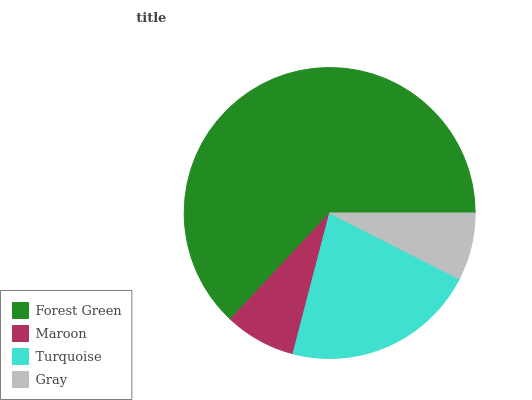Is Gray the minimum?
Answer yes or no. Yes. Is Forest Green the maximum?
Answer yes or no. Yes. Is Maroon the minimum?
Answer yes or no. No. Is Maroon the maximum?
Answer yes or no. No. Is Forest Green greater than Maroon?
Answer yes or no. Yes. Is Maroon less than Forest Green?
Answer yes or no. Yes. Is Maroon greater than Forest Green?
Answer yes or no. No. Is Forest Green less than Maroon?
Answer yes or no. No. Is Turquoise the high median?
Answer yes or no. Yes. Is Maroon the low median?
Answer yes or no. Yes. Is Maroon the high median?
Answer yes or no. No. Is Forest Green the low median?
Answer yes or no. No. 